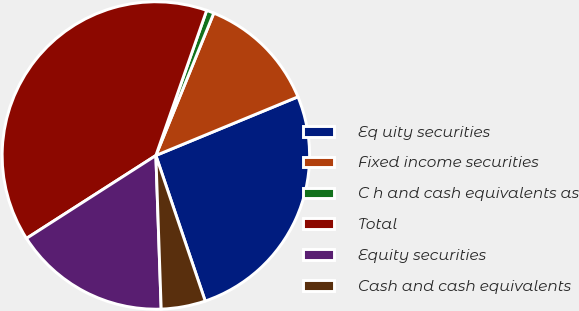Convert chart to OTSL. <chart><loc_0><loc_0><loc_500><loc_500><pie_chart><fcel>Eq uity securities<fcel>Fixed income securities<fcel>C h and cash equivalents as<fcel>Total<fcel>Equity securities<fcel>Cash and cash equivalents<nl><fcel>26.03%<fcel>12.62%<fcel>0.79%<fcel>39.43%<fcel>16.48%<fcel>4.65%<nl></chart> 